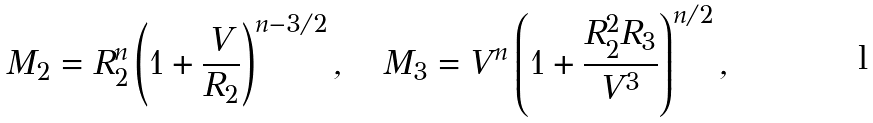<formula> <loc_0><loc_0><loc_500><loc_500>M _ { 2 } = R _ { 2 } ^ { n } \left ( 1 + \frac { V } { R _ { 2 } } \right ) ^ { n - 3 / 2 } , \quad M _ { 3 } = V ^ { n } \left ( 1 + \frac { R _ { 2 } ^ { 2 } R _ { 3 } } { V ^ { 3 } } \right ) ^ { n / 2 } ,</formula> 